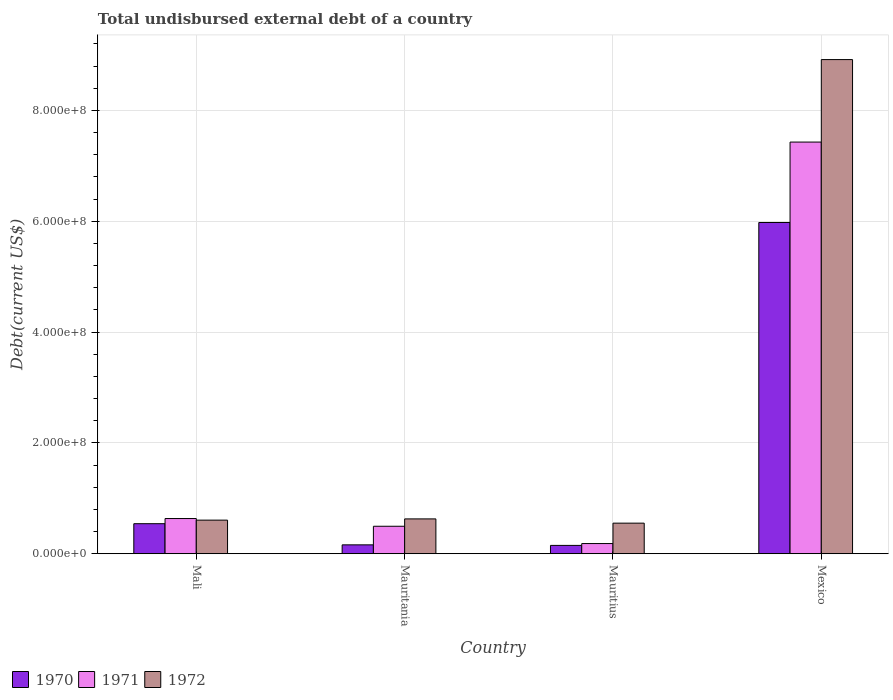How many different coloured bars are there?
Offer a terse response. 3. How many groups of bars are there?
Provide a succinct answer. 4. Are the number of bars per tick equal to the number of legend labels?
Provide a succinct answer. Yes. Are the number of bars on each tick of the X-axis equal?
Give a very brief answer. Yes. What is the label of the 1st group of bars from the left?
Your answer should be very brief. Mali. In how many cases, is the number of bars for a given country not equal to the number of legend labels?
Offer a very short reply. 0. What is the total undisbursed external debt in 1971 in Mali?
Keep it short and to the point. 6.35e+07. Across all countries, what is the maximum total undisbursed external debt in 1972?
Ensure brevity in your answer.  8.92e+08. Across all countries, what is the minimum total undisbursed external debt in 1970?
Keep it short and to the point. 1.50e+07. In which country was the total undisbursed external debt in 1970 minimum?
Your answer should be very brief. Mauritius. What is the total total undisbursed external debt in 1971 in the graph?
Offer a very short reply. 8.74e+08. What is the difference between the total undisbursed external debt in 1970 in Mali and that in Mexico?
Your answer should be very brief. -5.43e+08. What is the difference between the total undisbursed external debt in 1970 in Mexico and the total undisbursed external debt in 1972 in Mauritania?
Ensure brevity in your answer.  5.35e+08. What is the average total undisbursed external debt in 1970 per country?
Provide a short and direct response. 1.71e+08. What is the difference between the total undisbursed external debt of/in 1970 and total undisbursed external debt of/in 1972 in Mauritania?
Your response must be concise. -4.68e+07. In how many countries, is the total undisbursed external debt in 1970 greater than 360000000 US$?
Your answer should be compact. 1. What is the ratio of the total undisbursed external debt in 1970 in Mauritania to that in Mexico?
Ensure brevity in your answer.  0.03. Is the difference between the total undisbursed external debt in 1970 in Mali and Mauritius greater than the difference between the total undisbursed external debt in 1972 in Mali and Mauritius?
Your answer should be compact. Yes. What is the difference between the highest and the second highest total undisbursed external debt in 1972?
Make the answer very short. 8.31e+08. What is the difference between the highest and the lowest total undisbursed external debt in 1972?
Offer a very short reply. 8.36e+08. Is it the case that in every country, the sum of the total undisbursed external debt in 1972 and total undisbursed external debt in 1971 is greater than the total undisbursed external debt in 1970?
Your answer should be compact. Yes. Are the values on the major ticks of Y-axis written in scientific E-notation?
Make the answer very short. Yes. Does the graph contain any zero values?
Give a very brief answer. No. Where does the legend appear in the graph?
Give a very brief answer. Bottom left. How are the legend labels stacked?
Give a very brief answer. Horizontal. What is the title of the graph?
Keep it short and to the point. Total undisbursed external debt of a country. Does "1995" appear as one of the legend labels in the graph?
Ensure brevity in your answer.  No. What is the label or title of the X-axis?
Provide a succinct answer. Country. What is the label or title of the Y-axis?
Provide a succinct answer. Debt(current US$). What is the Debt(current US$) of 1970 in Mali?
Provide a succinct answer. 5.42e+07. What is the Debt(current US$) of 1971 in Mali?
Provide a short and direct response. 6.35e+07. What is the Debt(current US$) of 1972 in Mali?
Provide a short and direct response. 6.07e+07. What is the Debt(current US$) of 1970 in Mauritania?
Offer a terse response. 1.60e+07. What is the Debt(current US$) in 1971 in Mauritania?
Offer a terse response. 4.96e+07. What is the Debt(current US$) of 1972 in Mauritania?
Make the answer very short. 6.29e+07. What is the Debt(current US$) of 1970 in Mauritius?
Provide a succinct answer. 1.50e+07. What is the Debt(current US$) of 1971 in Mauritius?
Give a very brief answer. 1.84e+07. What is the Debt(current US$) of 1972 in Mauritius?
Offer a very short reply. 5.52e+07. What is the Debt(current US$) of 1970 in Mexico?
Your response must be concise. 5.98e+08. What is the Debt(current US$) of 1971 in Mexico?
Your response must be concise. 7.43e+08. What is the Debt(current US$) of 1972 in Mexico?
Offer a very short reply. 8.92e+08. Across all countries, what is the maximum Debt(current US$) in 1970?
Ensure brevity in your answer.  5.98e+08. Across all countries, what is the maximum Debt(current US$) of 1971?
Provide a short and direct response. 7.43e+08. Across all countries, what is the maximum Debt(current US$) in 1972?
Give a very brief answer. 8.92e+08. Across all countries, what is the minimum Debt(current US$) in 1970?
Offer a terse response. 1.50e+07. Across all countries, what is the minimum Debt(current US$) in 1971?
Ensure brevity in your answer.  1.84e+07. Across all countries, what is the minimum Debt(current US$) of 1972?
Offer a terse response. 5.52e+07. What is the total Debt(current US$) in 1970 in the graph?
Give a very brief answer. 6.83e+08. What is the total Debt(current US$) in 1971 in the graph?
Provide a short and direct response. 8.74e+08. What is the total Debt(current US$) in 1972 in the graph?
Make the answer very short. 1.07e+09. What is the difference between the Debt(current US$) of 1970 in Mali and that in Mauritania?
Make the answer very short. 3.82e+07. What is the difference between the Debt(current US$) in 1971 in Mali and that in Mauritania?
Offer a very short reply. 1.39e+07. What is the difference between the Debt(current US$) of 1972 in Mali and that in Mauritania?
Ensure brevity in your answer.  -2.22e+06. What is the difference between the Debt(current US$) of 1970 in Mali and that in Mauritius?
Keep it short and to the point. 3.92e+07. What is the difference between the Debt(current US$) in 1971 in Mali and that in Mauritius?
Provide a short and direct response. 4.51e+07. What is the difference between the Debt(current US$) of 1972 in Mali and that in Mauritius?
Give a very brief answer. 5.45e+06. What is the difference between the Debt(current US$) of 1970 in Mali and that in Mexico?
Your answer should be very brief. -5.43e+08. What is the difference between the Debt(current US$) in 1971 in Mali and that in Mexico?
Offer a very short reply. -6.79e+08. What is the difference between the Debt(current US$) in 1972 in Mali and that in Mexico?
Provide a succinct answer. -8.31e+08. What is the difference between the Debt(current US$) of 1970 in Mauritania and that in Mauritius?
Offer a very short reply. 9.95e+05. What is the difference between the Debt(current US$) of 1971 in Mauritania and that in Mauritius?
Your answer should be compact. 3.12e+07. What is the difference between the Debt(current US$) of 1972 in Mauritania and that in Mauritius?
Your response must be concise. 7.67e+06. What is the difference between the Debt(current US$) in 1970 in Mauritania and that in Mexico?
Keep it short and to the point. -5.82e+08. What is the difference between the Debt(current US$) in 1971 in Mauritania and that in Mexico?
Provide a short and direct response. -6.93e+08. What is the difference between the Debt(current US$) of 1972 in Mauritania and that in Mexico?
Provide a succinct answer. -8.29e+08. What is the difference between the Debt(current US$) in 1970 in Mauritius and that in Mexico?
Ensure brevity in your answer.  -5.83e+08. What is the difference between the Debt(current US$) in 1971 in Mauritius and that in Mexico?
Ensure brevity in your answer.  -7.24e+08. What is the difference between the Debt(current US$) of 1972 in Mauritius and that in Mexico?
Make the answer very short. -8.36e+08. What is the difference between the Debt(current US$) of 1970 in Mali and the Debt(current US$) of 1971 in Mauritania?
Offer a very short reply. 4.64e+06. What is the difference between the Debt(current US$) of 1970 in Mali and the Debt(current US$) of 1972 in Mauritania?
Offer a very short reply. -8.65e+06. What is the difference between the Debt(current US$) of 1971 in Mali and the Debt(current US$) of 1972 in Mauritania?
Offer a terse response. 6.38e+05. What is the difference between the Debt(current US$) of 1970 in Mali and the Debt(current US$) of 1971 in Mauritius?
Give a very brief answer. 3.59e+07. What is the difference between the Debt(current US$) in 1970 in Mali and the Debt(current US$) in 1972 in Mauritius?
Offer a very short reply. -9.81e+05. What is the difference between the Debt(current US$) in 1971 in Mali and the Debt(current US$) in 1972 in Mauritius?
Keep it short and to the point. 8.31e+06. What is the difference between the Debt(current US$) of 1970 in Mali and the Debt(current US$) of 1971 in Mexico?
Offer a very short reply. -6.89e+08. What is the difference between the Debt(current US$) in 1970 in Mali and the Debt(current US$) in 1972 in Mexico?
Provide a short and direct response. -8.37e+08. What is the difference between the Debt(current US$) of 1971 in Mali and the Debt(current US$) of 1972 in Mexico?
Offer a very short reply. -8.28e+08. What is the difference between the Debt(current US$) of 1970 in Mauritania and the Debt(current US$) of 1971 in Mauritius?
Give a very brief answer. -2.33e+06. What is the difference between the Debt(current US$) of 1970 in Mauritania and the Debt(current US$) of 1972 in Mauritius?
Offer a terse response. -3.92e+07. What is the difference between the Debt(current US$) in 1971 in Mauritania and the Debt(current US$) in 1972 in Mauritius?
Provide a short and direct response. -5.62e+06. What is the difference between the Debt(current US$) of 1970 in Mauritania and the Debt(current US$) of 1971 in Mexico?
Your answer should be compact. -7.27e+08. What is the difference between the Debt(current US$) of 1970 in Mauritania and the Debt(current US$) of 1972 in Mexico?
Your answer should be very brief. -8.76e+08. What is the difference between the Debt(current US$) in 1971 in Mauritania and the Debt(current US$) in 1972 in Mexico?
Offer a very short reply. -8.42e+08. What is the difference between the Debt(current US$) of 1970 in Mauritius and the Debt(current US$) of 1971 in Mexico?
Keep it short and to the point. -7.28e+08. What is the difference between the Debt(current US$) of 1970 in Mauritius and the Debt(current US$) of 1972 in Mexico?
Give a very brief answer. -8.77e+08. What is the difference between the Debt(current US$) of 1971 in Mauritius and the Debt(current US$) of 1972 in Mexico?
Your answer should be compact. -8.73e+08. What is the average Debt(current US$) in 1970 per country?
Provide a short and direct response. 1.71e+08. What is the average Debt(current US$) of 1971 per country?
Provide a short and direct response. 2.19e+08. What is the average Debt(current US$) in 1972 per country?
Make the answer very short. 2.68e+08. What is the difference between the Debt(current US$) of 1970 and Debt(current US$) of 1971 in Mali?
Give a very brief answer. -9.29e+06. What is the difference between the Debt(current US$) in 1970 and Debt(current US$) in 1972 in Mali?
Your answer should be very brief. -6.43e+06. What is the difference between the Debt(current US$) of 1971 and Debt(current US$) of 1972 in Mali?
Your answer should be very brief. 2.86e+06. What is the difference between the Debt(current US$) of 1970 and Debt(current US$) of 1971 in Mauritania?
Provide a short and direct response. -3.35e+07. What is the difference between the Debt(current US$) of 1970 and Debt(current US$) of 1972 in Mauritania?
Keep it short and to the point. -4.68e+07. What is the difference between the Debt(current US$) in 1971 and Debt(current US$) in 1972 in Mauritania?
Your answer should be very brief. -1.33e+07. What is the difference between the Debt(current US$) in 1970 and Debt(current US$) in 1971 in Mauritius?
Your answer should be compact. -3.32e+06. What is the difference between the Debt(current US$) in 1970 and Debt(current US$) in 1972 in Mauritius?
Offer a terse response. -4.02e+07. What is the difference between the Debt(current US$) of 1971 and Debt(current US$) of 1972 in Mauritius?
Offer a terse response. -3.68e+07. What is the difference between the Debt(current US$) in 1970 and Debt(current US$) in 1971 in Mexico?
Give a very brief answer. -1.45e+08. What is the difference between the Debt(current US$) in 1970 and Debt(current US$) in 1972 in Mexico?
Your response must be concise. -2.94e+08. What is the difference between the Debt(current US$) of 1971 and Debt(current US$) of 1972 in Mexico?
Offer a terse response. -1.49e+08. What is the ratio of the Debt(current US$) in 1970 in Mali to that in Mauritania?
Ensure brevity in your answer.  3.38. What is the ratio of the Debt(current US$) of 1971 in Mali to that in Mauritania?
Give a very brief answer. 1.28. What is the ratio of the Debt(current US$) of 1972 in Mali to that in Mauritania?
Keep it short and to the point. 0.96. What is the ratio of the Debt(current US$) of 1970 in Mali to that in Mauritius?
Give a very brief answer. 3.6. What is the ratio of the Debt(current US$) in 1971 in Mali to that in Mauritius?
Make the answer very short. 3.46. What is the ratio of the Debt(current US$) of 1972 in Mali to that in Mauritius?
Offer a very short reply. 1.1. What is the ratio of the Debt(current US$) in 1970 in Mali to that in Mexico?
Make the answer very short. 0.09. What is the ratio of the Debt(current US$) in 1971 in Mali to that in Mexico?
Offer a terse response. 0.09. What is the ratio of the Debt(current US$) of 1972 in Mali to that in Mexico?
Offer a terse response. 0.07. What is the ratio of the Debt(current US$) in 1970 in Mauritania to that in Mauritius?
Offer a very short reply. 1.07. What is the ratio of the Debt(current US$) in 1971 in Mauritania to that in Mauritius?
Make the answer very short. 2.7. What is the ratio of the Debt(current US$) in 1972 in Mauritania to that in Mauritius?
Your response must be concise. 1.14. What is the ratio of the Debt(current US$) of 1970 in Mauritania to that in Mexico?
Offer a terse response. 0.03. What is the ratio of the Debt(current US$) in 1971 in Mauritania to that in Mexico?
Your answer should be very brief. 0.07. What is the ratio of the Debt(current US$) in 1972 in Mauritania to that in Mexico?
Your answer should be very brief. 0.07. What is the ratio of the Debt(current US$) of 1970 in Mauritius to that in Mexico?
Give a very brief answer. 0.03. What is the ratio of the Debt(current US$) in 1971 in Mauritius to that in Mexico?
Provide a succinct answer. 0.02. What is the ratio of the Debt(current US$) in 1972 in Mauritius to that in Mexico?
Offer a terse response. 0.06. What is the difference between the highest and the second highest Debt(current US$) of 1970?
Provide a short and direct response. 5.43e+08. What is the difference between the highest and the second highest Debt(current US$) of 1971?
Ensure brevity in your answer.  6.79e+08. What is the difference between the highest and the second highest Debt(current US$) of 1972?
Make the answer very short. 8.29e+08. What is the difference between the highest and the lowest Debt(current US$) in 1970?
Provide a succinct answer. 5.83e+08. What is the difference between the highest and the lowest Debt(current US$) in 1971?
Provide a short and direct response. 7.24e+08. What is the difference between the highest and the lowest Debt(current US$) of 1972?
Offer a terse response. 8.36e+08. 